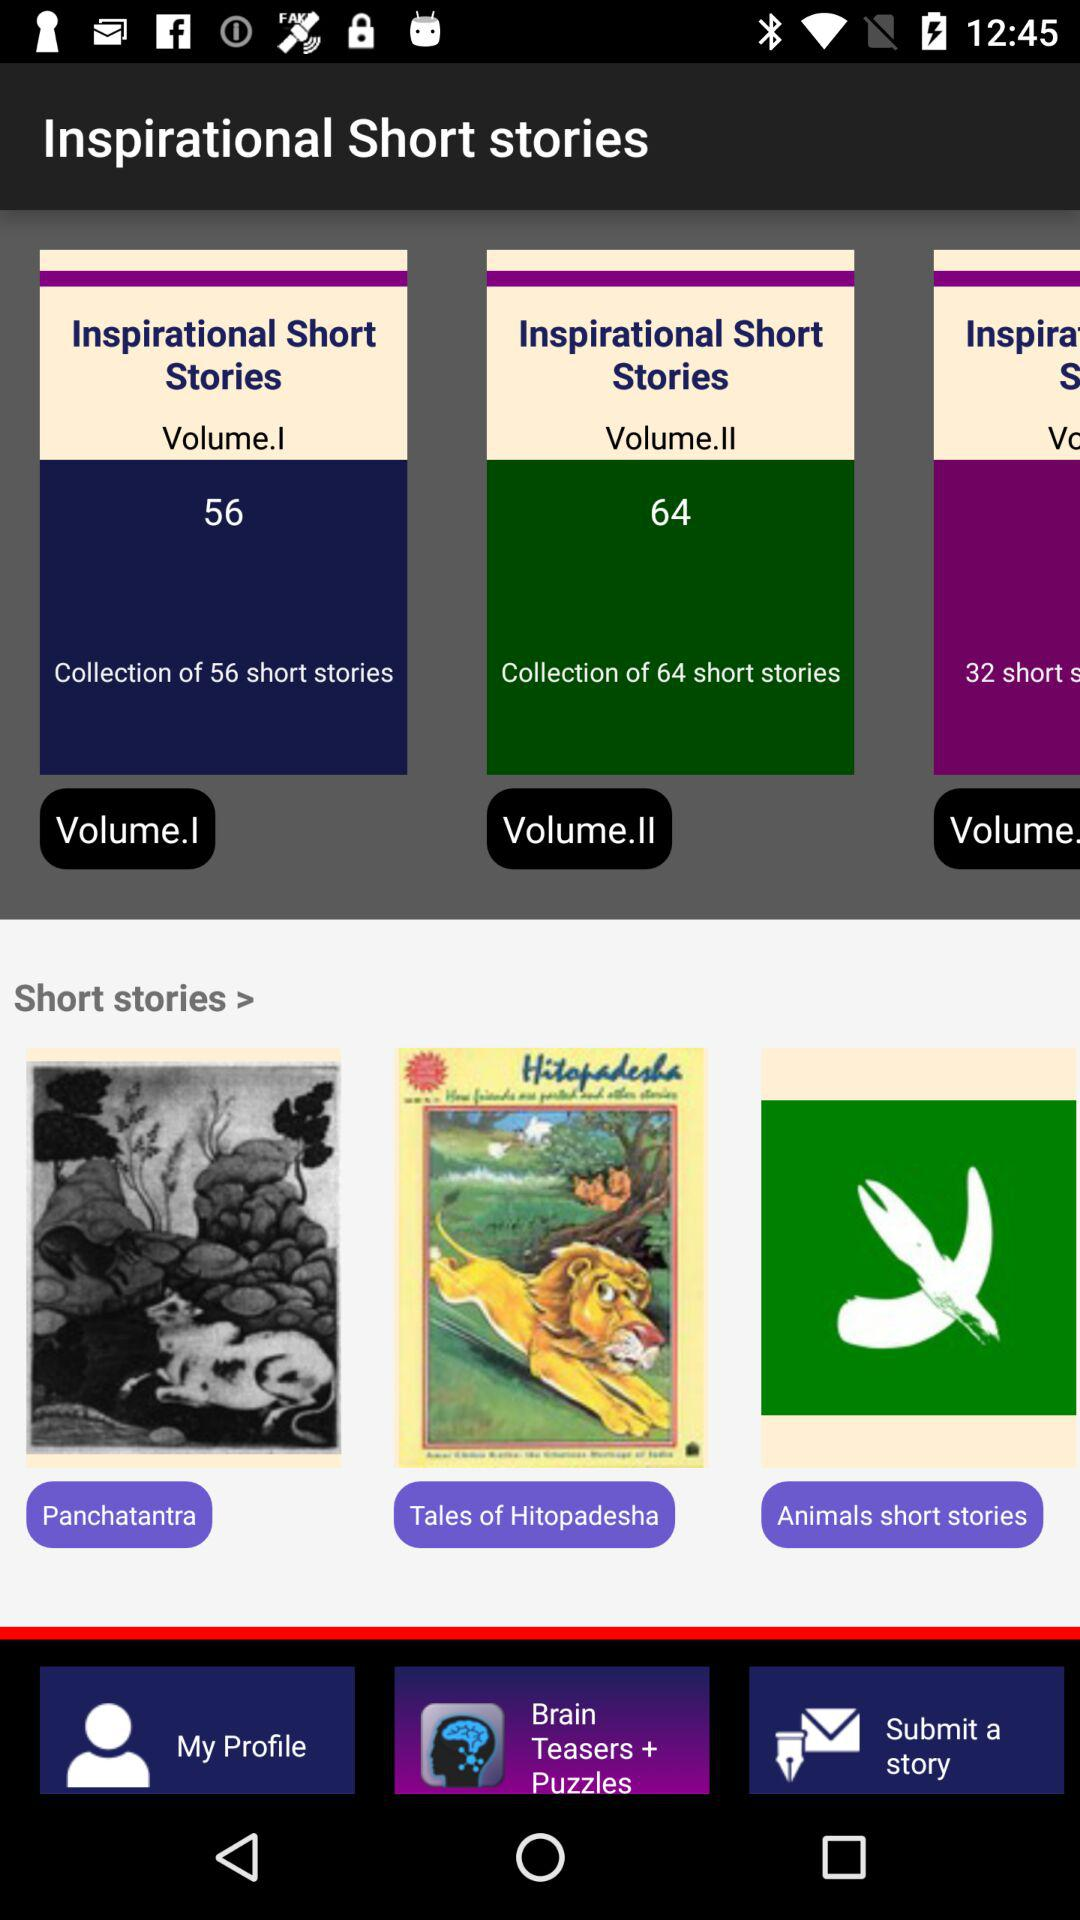How many more short stories are in the second volume of Inspirational Short Stories than the first?
Answer the question using a single word or phrase. 8 